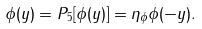Convert formula to latex. <formula><loc_0><loc_0><loc_500><loc_500>\phi ( y ) = P _ { 5 } [ \phi ( y ) ] = \eta _ { \phi } \phi ( - y ) .</formula> 